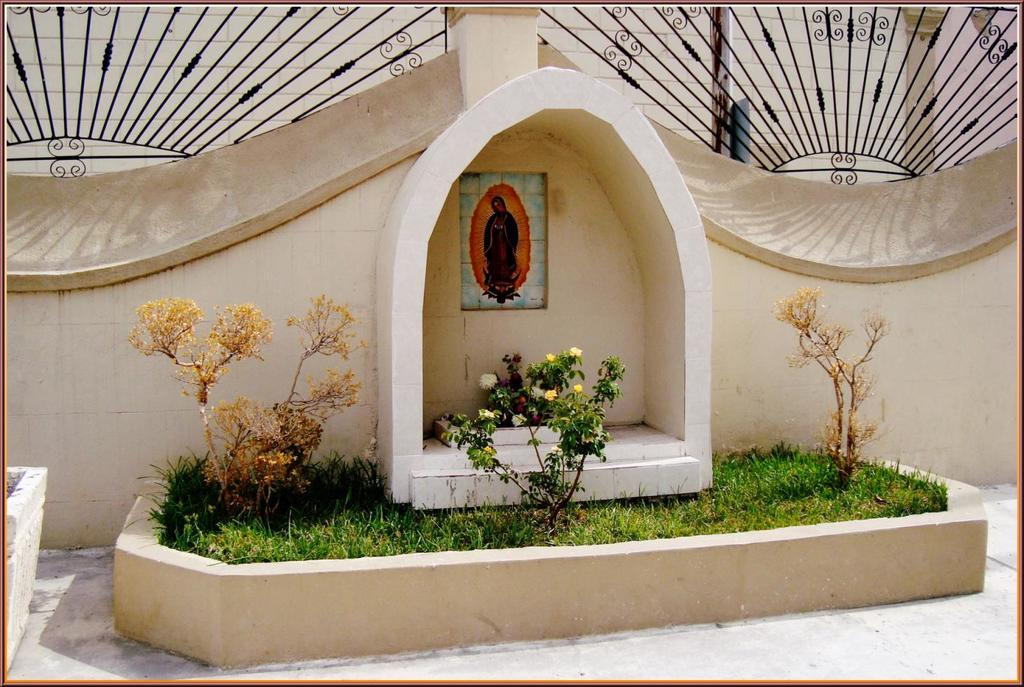What is present on the wall in the image? There is a photo of Jesus on the wall. What type of landscape can be seen in the image? There is grassland in the image. What other natural elements are visible in the image? There are plants in the image. What is at the top of the wall? There is an iron fence at the top of the wall. Can you see any letters being passed between friends in the image? There are no letters or friends present in the image. What type of cord is used to hang the photo of Jesus on the wall? There is no mention of a cord being used to hang the photo of Jesus on the wall in the provided facts. 